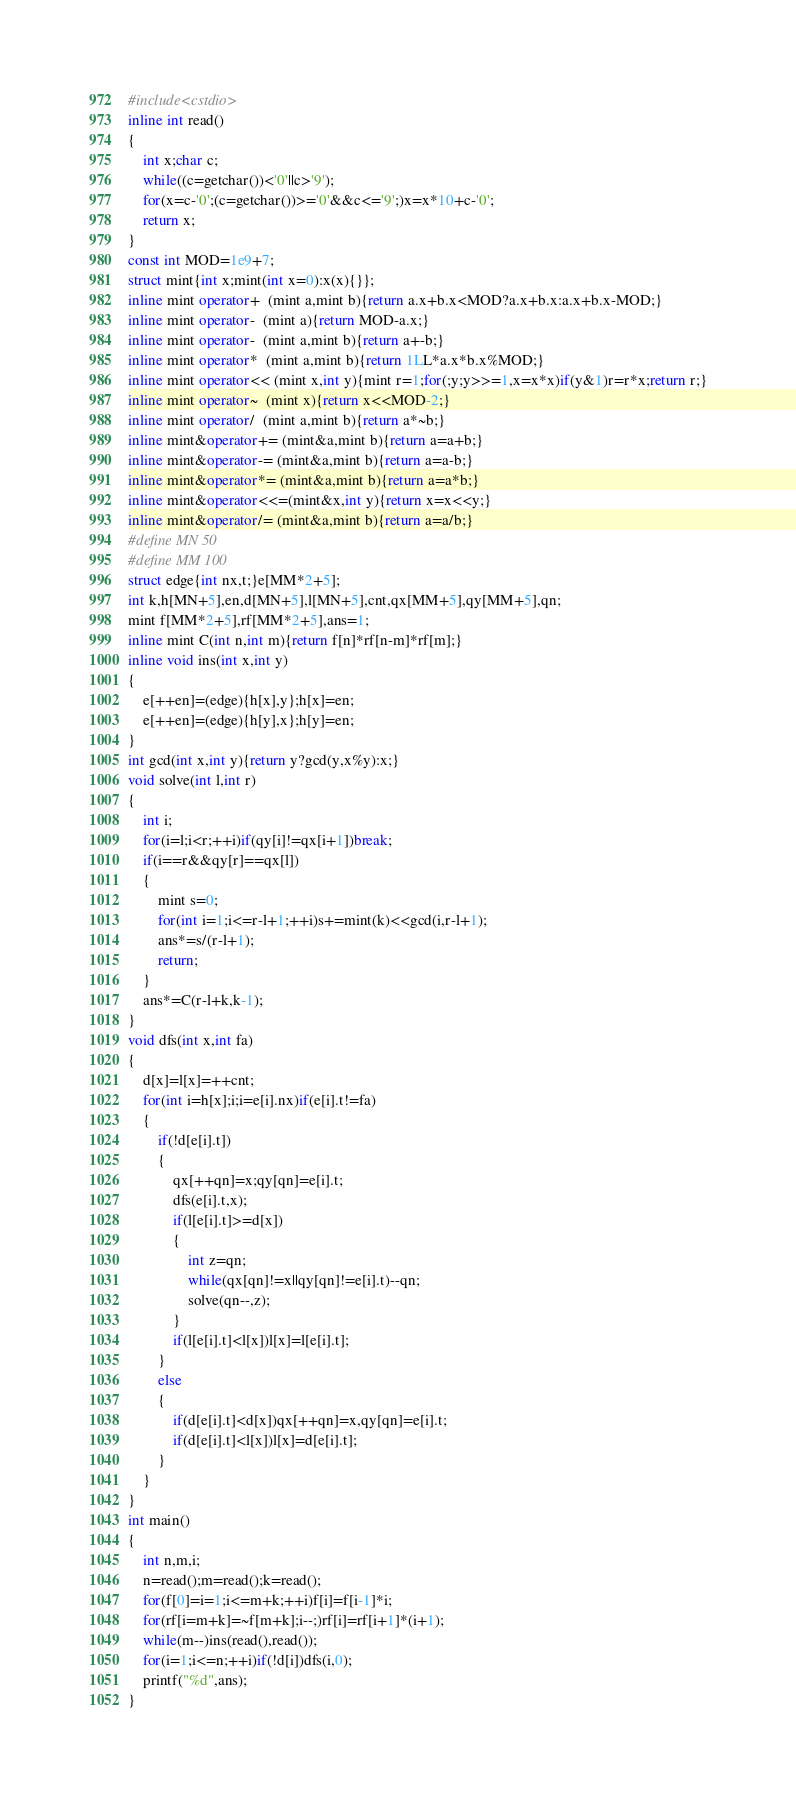Convert code to text. <code><loc_0><loc_0><loc_500><loc_500><_C++_>#include<cstdio>
inline int read()
{
	int x;char c;
	while((c=getchar())<'0'||c>'9');
	for(x=c-'0';(c=getchar())>='0'&&c<='9';)x=x*10+c-'0';
	return x;
}
const int MOD=1e9+7;
struct mint{int x;mint(int x=0):x(x){}};
inline mint operator+  (mint a,mint b){return a.x+b.x<MOD?a.x+b.x:a.x+b.x-MOD;}
inline mint operator-  (mint a){return MOD-a.x;}
inline mint operator-  (mint a,mint b){return a+-b;}
inline mint operator*  (mint a,mint b){return 1LL*a.x*b.x%MOD;}
inline mint operator<< (mint x,int y){mint r=1;for(;y;y>>=1,x=x*x)if(y&1)r=r*x;return r;}
inline mint operator~  (mint x){return x<<MOD-2;}
inline mint operator/  (mint a,mint b){return a*~b;}
inline mint&operator+= (mint&a,mint b){return a=a+b;}
inline mint&operator-= (mint&a,mint b){return a=a-b;}
inline mint&operator*= (mint&a,mint b){return a=a*b;}
inline mint&operator<<=(mint&x,int y){return x=x<<y;}
inline mint&operator/= (mint&a,mint b){return a=a/b;}
#define MN 50
#define MM 100
struct edge{int nx,t;}e[MM*2+5];
int k,h[MN+5],en,d[MN+5],l[MN+5],cnt,qx[MM+5],qy[MM+5],qn;
mint f[MM*2+5],rf[MM*2+5],ans=1;
inline mint C(int n,int m){return f[n]*rf[n-m]*rf[m];}
inline void ins(int x,int y)
{
	e[++en]=(edge){h[x],y};h[x]=en;
	e[++en]=(edge){h[y],x};h[y]=en;
}
int gcd(int x,int y){return y?gcd(y,x%y):x;}
void solve(int l,int r)
{
	int i;
	for(i=l;i<r;++i)if(qy[i]!=qx[i+1])break;
	if(i==r&&qy[r]==qx[l])
	{
		mint s=0;
		for(int i=1;i<=r-l+1;++i)s+=mint(k)<<gcd(i,r-l+1);
		ans*=s/(r-l+1);
		return;
	}
	ans*=C(r-l+k,k-1);
}
void dfs(int x,int fa)
{
	d[x]=l[x]=++cnt;
	for(int i=h[x];i;i=e[i].nx)if(e[i].t!=fa)
	{
		if(!d[e[i].t])
		{
			qx[++qn]=x;qy[qn]=e[i].t;
			dfs(e[i].t,x);
			if(l[e[i].t]>=d[x])
			{
				int z=qn;
				while(qx[qn]!=x||qy[qn]!=e[i].t)--qn;
				solve(qn--,z);
			}
			if(l[e[i].t]<l[x])l[x]=l[e[i].t];
		}
		else
		{
			if(d[e[i].t]<d[x])qx[++qn]=x,qy[qn]=e[i].t;
			if(d[e[i].t]<l[x])l[x]=d[e[i].t];
		}
	}
}
int main()
{
	int n,m,i;
	n=read();m=read();k=read();
	for(f[0]=i=1;i<=m+k;++i)f[i]=f[i-1]*i;
	for(rf[i=m+k]=~f[m+k];i--;)rf[i]=rf[i+1]*(i+1);
	while(m--)ins(read(),read());
	for(i=1;i<=n;++i)if(!d[i])dfs(i,0);
	printf("%d",ans); 
}</code> 